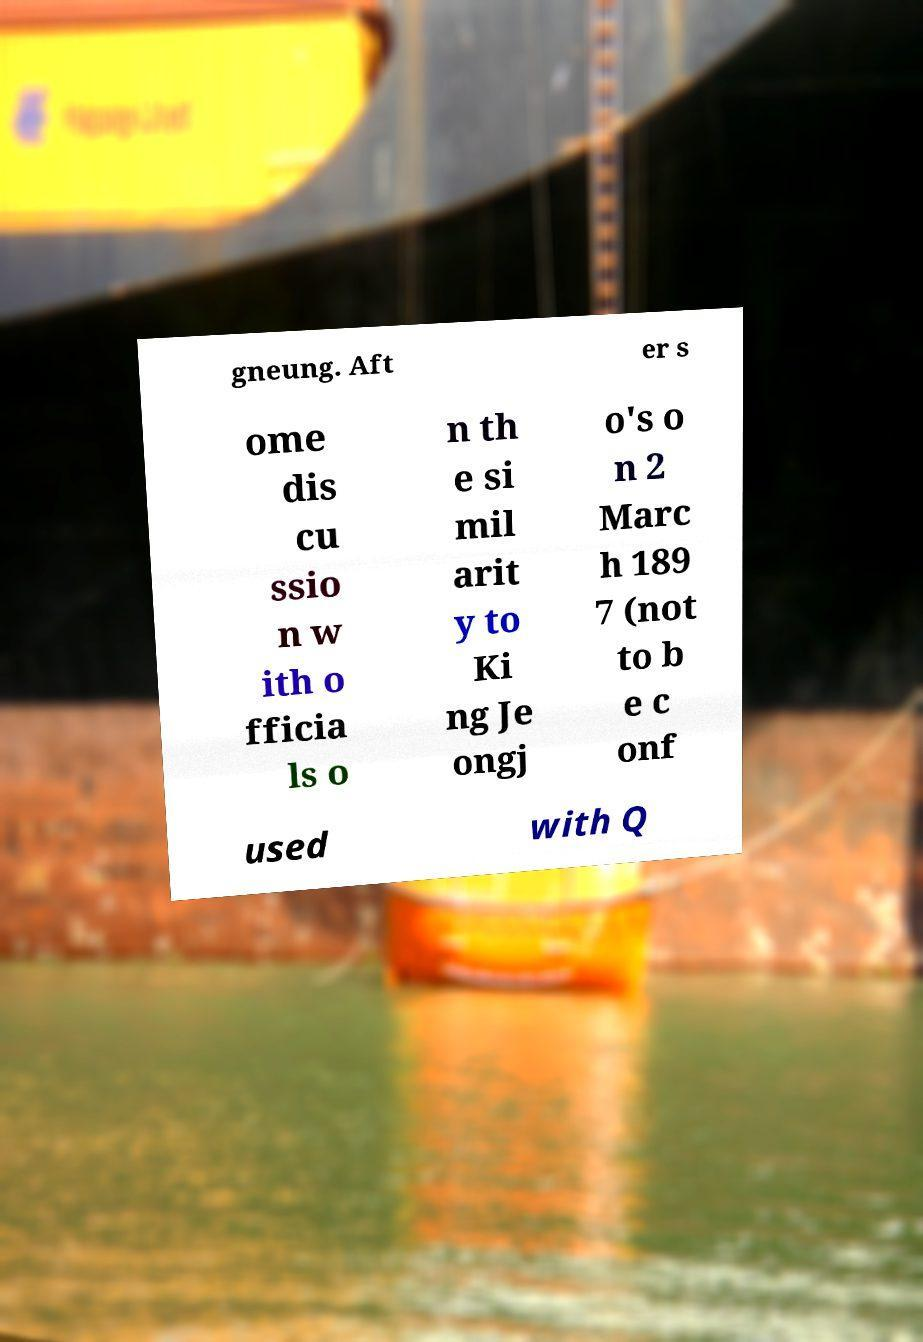What messages or text are displayed in this image? I need them in a readable, typed format. gneung. Aft er s ome dis cu ssio n w ith o fficia ls o n th e si mil arit y to Ki ng Je ongj o's o n 2 Marc h 189 7 (not to b e c onf used with Q 